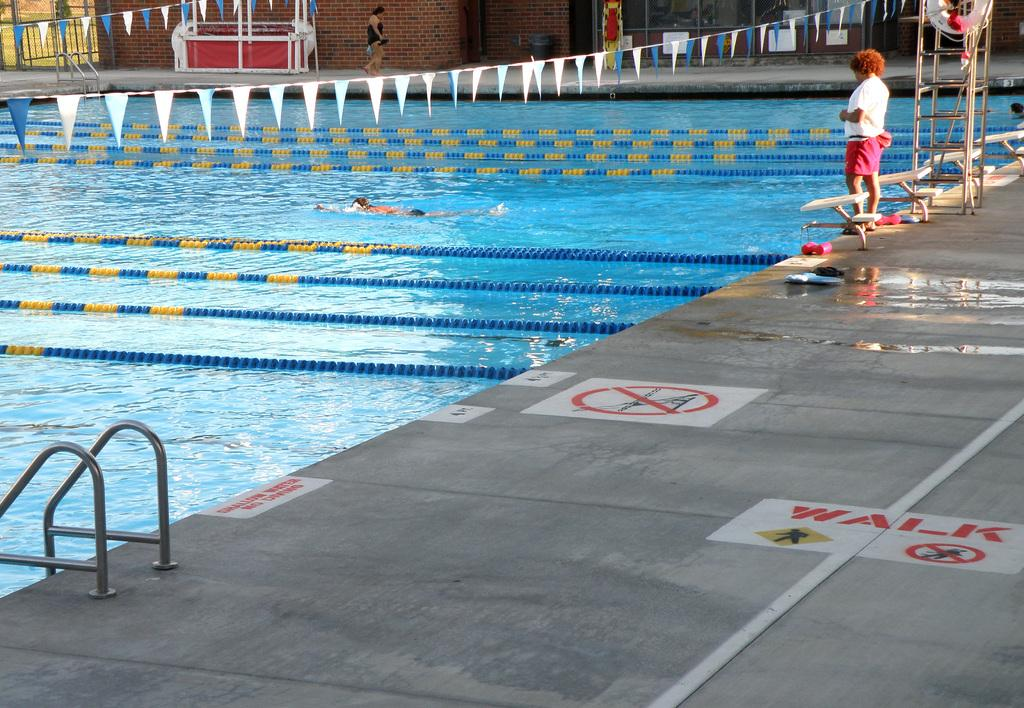What is the main feature of the image? There is a swimming pool in the image. Are there any people in the image? Yes, there are two ladies in the image. What can be used to enter or exit the swimming pool? There is a ladder in the image. What other object can be seen in the image? There is a desk in the image. Where is the desk located in the image? The desk is located at the top side of the image. What type of trade is being conducted in the image? There is no indication of any trade being conducted in the image. Can you see a fan in the image? There is no fan present in the image. 